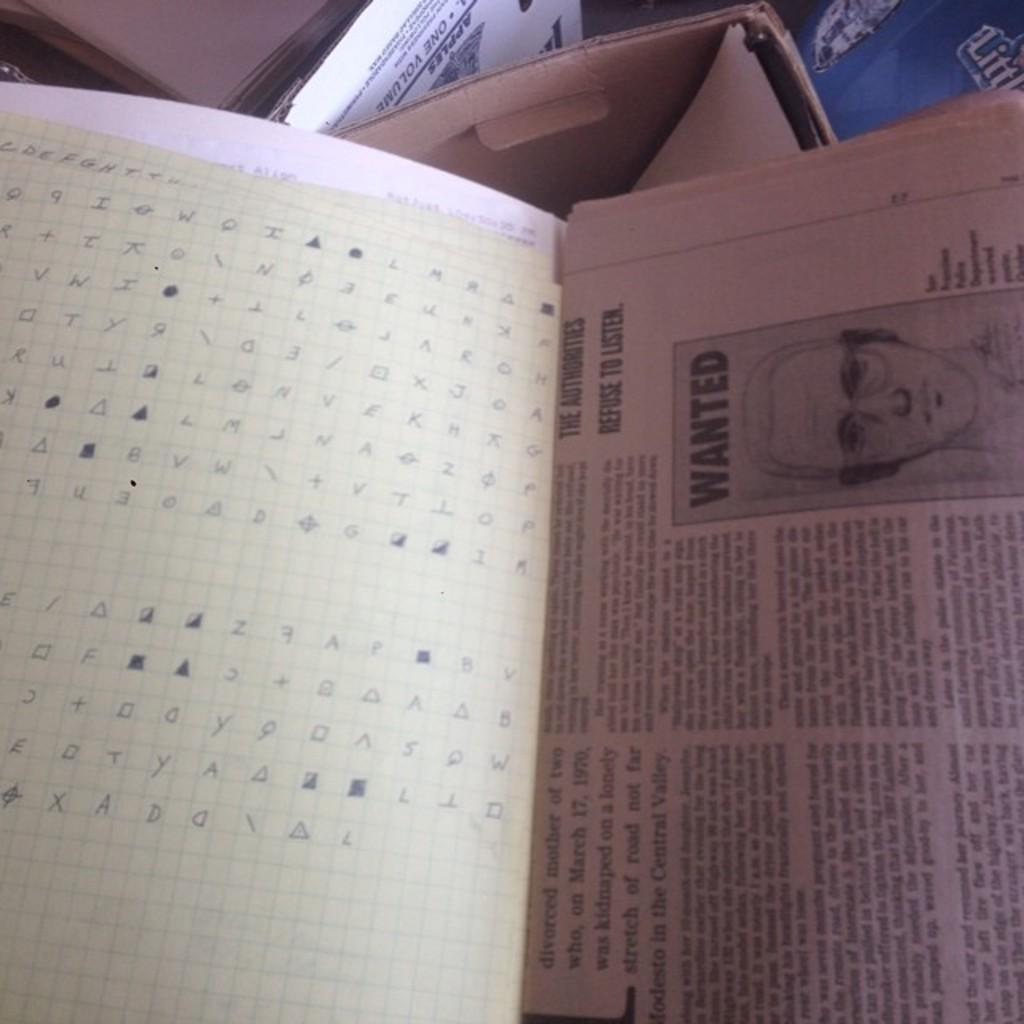Provide a one-sentence caption for the provided image. A code is written out on a piece of graph paper, next to a newspaper article with a sketch of a wanted man. 